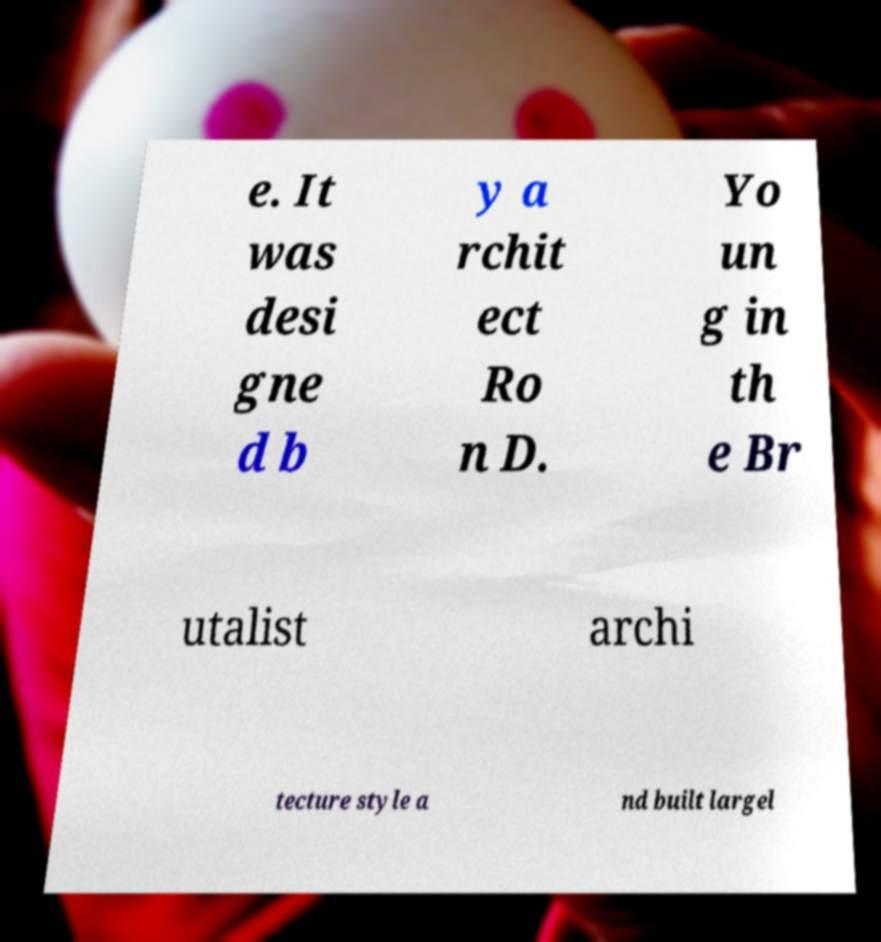Could you assist in decoding the text presented in this image and type it out clearly? e. It was desi gne d b y a rchit ect Ro n D. Yo un g in th e Br utalist archi tecture style a nd built largel 